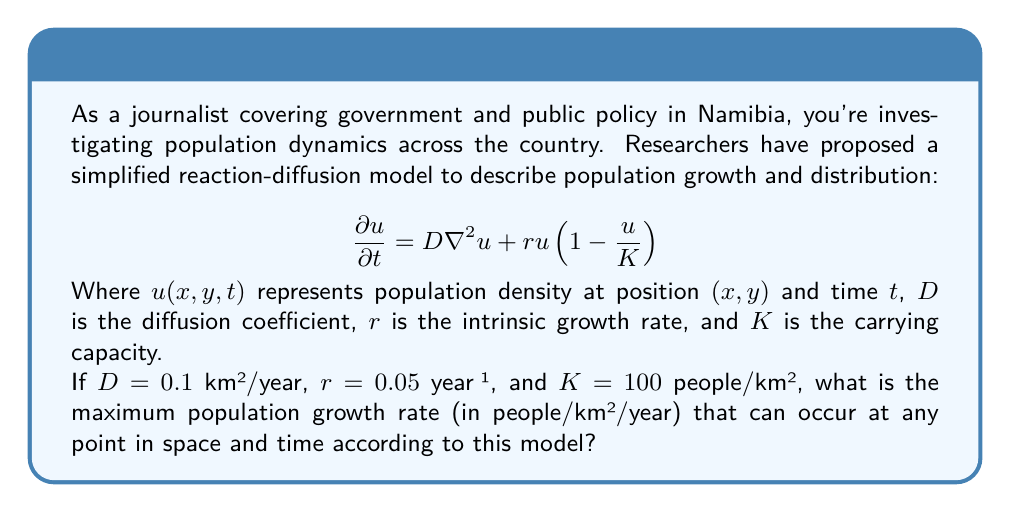Give your solution to this math problem. To solve this problem, we need to analyze the reaction-diffusion equation:

$$\frac{\partial u}{\partial t} = D\nabla^2u + ru(1-\frac{u}{K})$$

The term $ru(1-\frac{u}{K})$ represents the local population growth rate. To find the maximum growth rate, we need to maximize this term with respect to $u$.

Let's define $f(u) = ru(1-\frac{u}{K})$.

To find the maximum of $f(u)$, we differentiate and set it to zero:

$$\frac{df}{du} = r(1-\frac{u}{K}) - r\frac{u}{K} = r - \frac{2ru}{K}$$

Setting this equal to zero:

$$r - \frac{2ru}{K} = 0$$
$$r = \frac{2ru}{K}$$
$$K = 2u$$
$$u = \frac{K}{2}$$

This critical point occurs at $u = \frac{K}{2}$, which is half the carrying capacity.

To verify it's a maximum, we can check the second derivative:

$$\frac{d^2f}{du^2} = -\frac{2r}{K}$$

This is negative, confirming that $u = \frac{K}{2}$ gives a maximum.

Now, we can calculate the maximum growth rate by substituting $u = \frac{K}{2}$ into $f(u)$:

$$f(\frac{K}{2}) = r\frac{K}{2}(1-\frac{\frac{K}{2}}{K}) = r\frac{K}{2}(1-\frac{1}{2}) = r\frac{K}{2}\cdot\frac{1}{2} = \frac{rK}{4}$$

Substituting the given values:

$$\text{Maximum growth rate} = \frac{rK}{4} = \frac{0.05 \cdot 100}{4} = 1.25 \text{ people/km²/year}$$
Answer: The maximum population growth rate is 1.25 people/km²/year. 